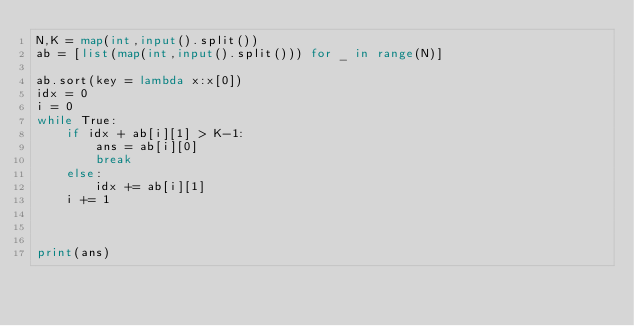Convert code to text. <code><loc_0><loc_0><loc_500><loc_500><_Python_>N,K = map(int,input().split())
ab = [list(map(int,input().split())) for _ in range(N)]

ab.sort(key = lambda x:x[0])
idx = 0
i = 0
while True:
    if idx + ab[i][1] > K-1:
        ans = ab[i][0]
        break
    else:
        idx += ab[i][1]
    i += 1
    


print(ans)  
    </code> 